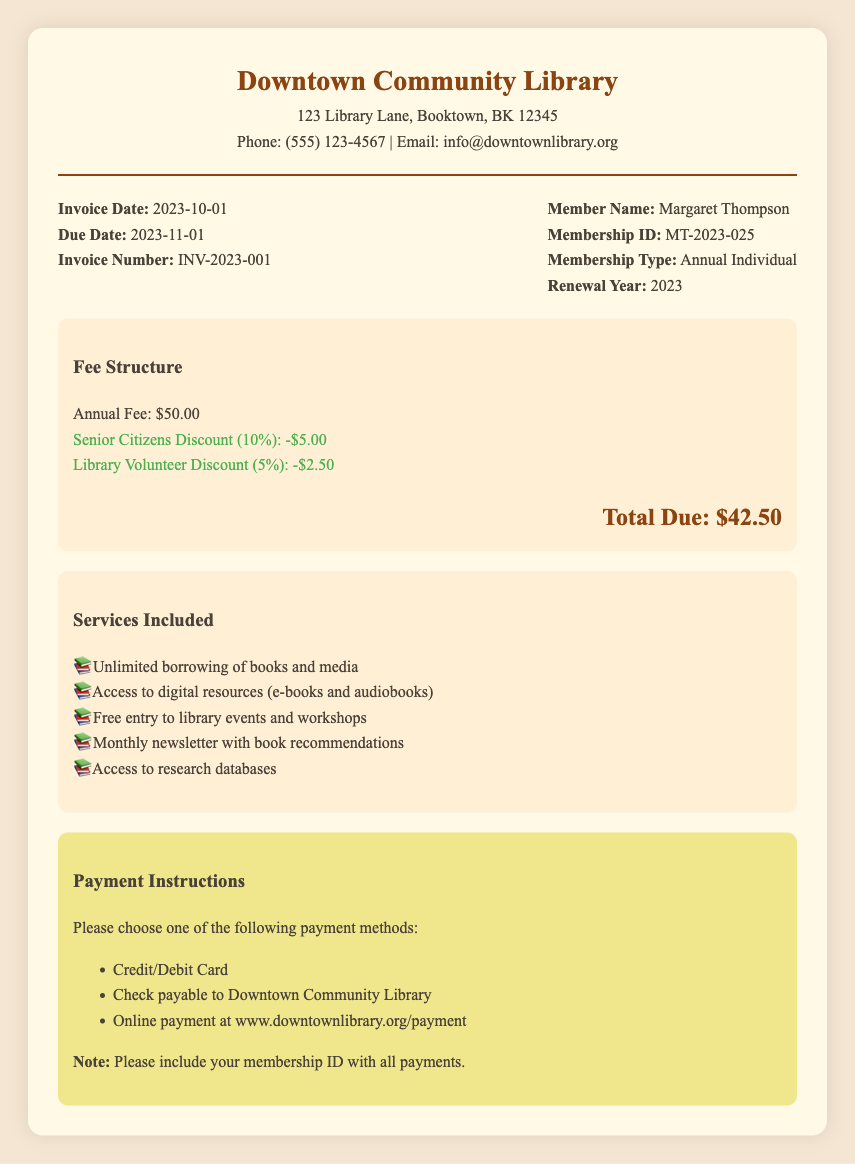What is the annual fee for membership? The annual fee is listed clearly under the fee structure.
Answer: $50.00 What discounts are applied to the total fee? The document lists two discounts: one for senior citizens and another for library volunteers.
Answer: Senior Citizens Discount (10%): -$5.00; Library Volunteer Discount (5%): -$2.50 What is the total amount due for renewal? The total is calculated after applying the discounts to the annual fee.
Answer: $42.50 When is the payment due date? The due date is indicated in the invoice details section of the document.
Answer: 2023-11-01 What is the membership type of the member? The type of membership is specified in the member details section.
Answer: Annual Individual Who is the member named in the invoice? The member's name is prominently displayed in the invoice details.
Answer: Margaret Thompson What payment methods are available? The document outlines several payment methods for the member to choose from.
Answer: Credit/Debit Card, Check, Online payment How many services are included with the membership? The services included are enumerated in a list under the services section.
Answer: Five services What is the invoice number? The invoice number is specified in the invoice details section.
Answer: INV-2023-001 What is the library's phone number? The phone number is provided in the contact details of the library.
Answer: (555) 123-4567 